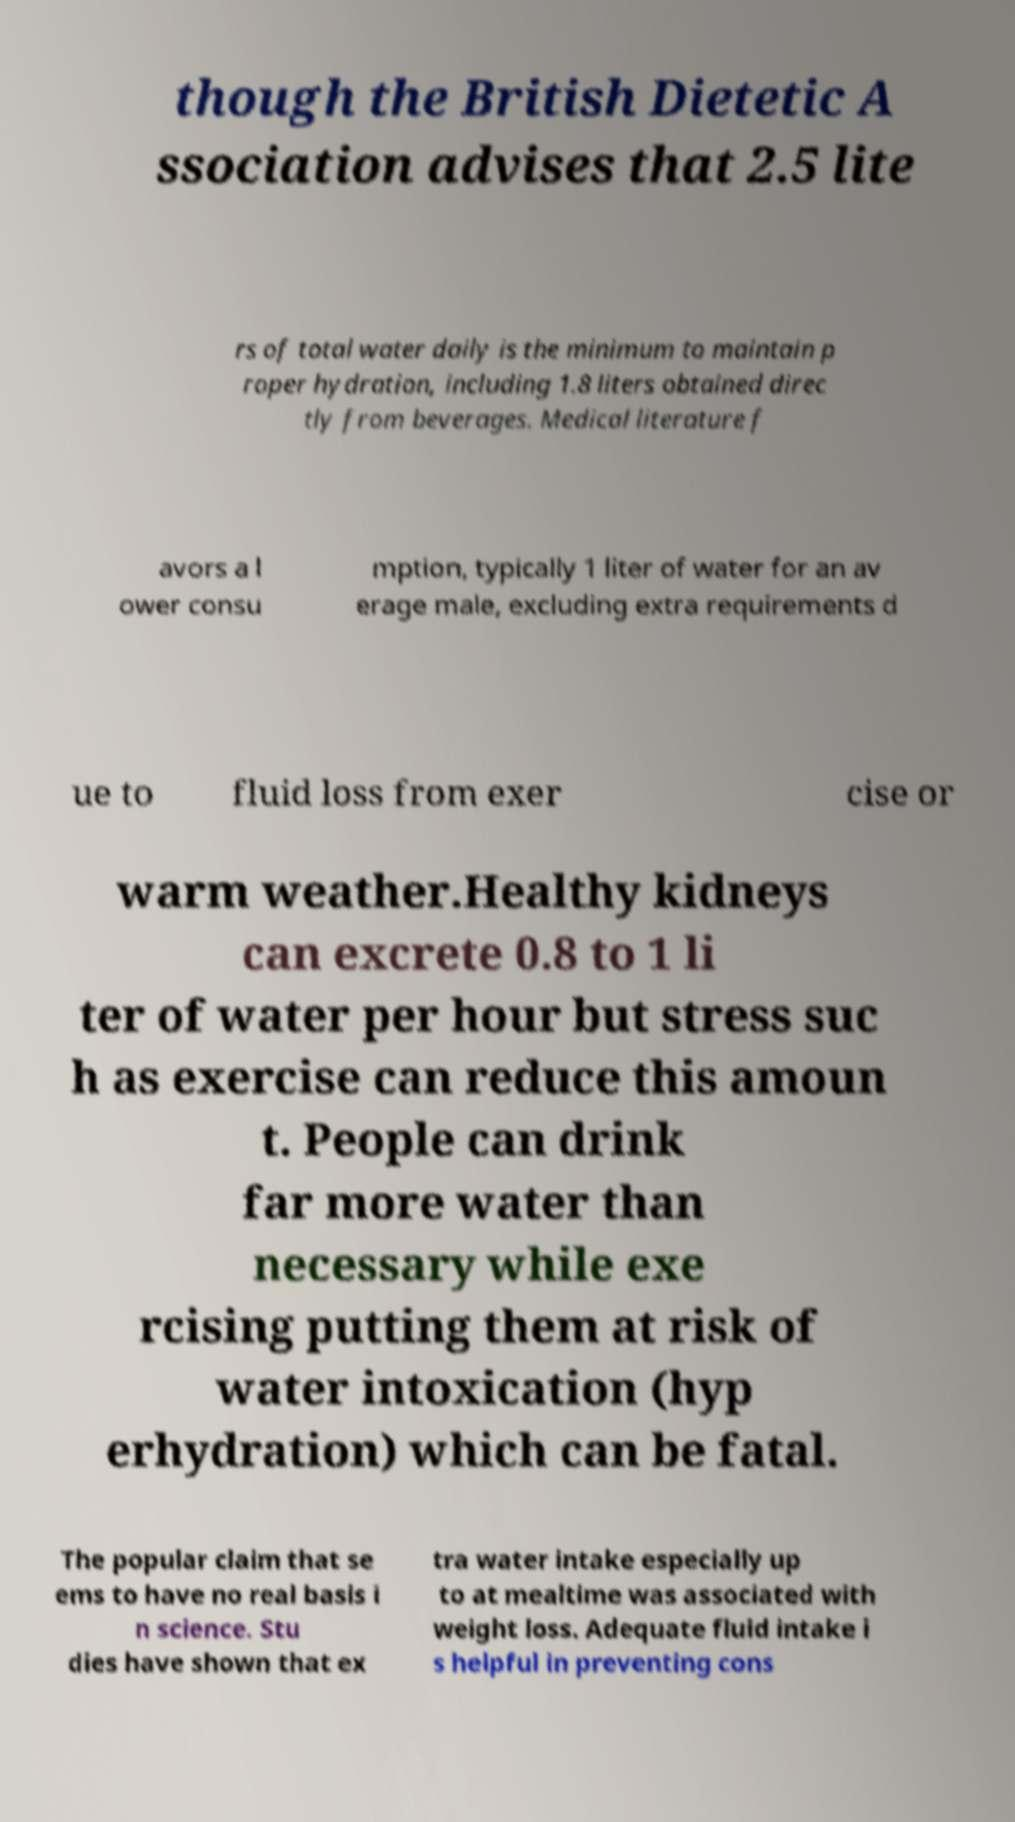Please read and relay the text visible in this image. What does it say? though the British Dietetic A ssociation advises that 2.5 lite rs of total water daily is the minimum to maintain p roper hydration, including 1.8 liters obtained direc tly from beverages. Medical literature f avors a l ower consu mption, typically 1 liter of water for an av erage male, excluding extra requirements d ue to fluid loss from exer cise or warm weather.Healthy kidneys can excrete 0.8 to 1 li ter of water per hour but stress suc h as exercise can reduce this amoun t. People can drink far more water than necessary while exe rcising putting them at risk of water intoxication (hyp erhydration) which can be fatal. The popular claim that se ems to have no real basis i n science. Stu dies have shown that ex tra water intake especially up to at mealtime was associated with weight loss. Adequate fluid intake i s helpful in preventing cons 